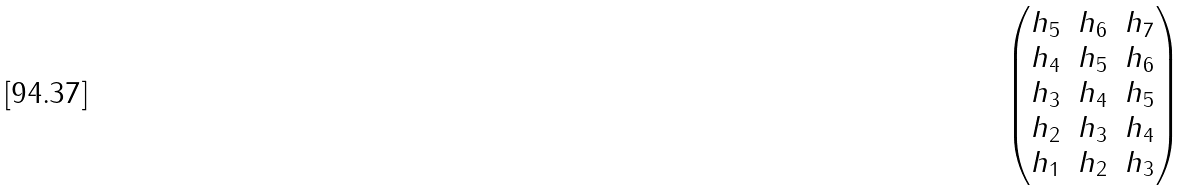Convert formula to latex. <formula><loc_0><loc_0><loc_500><loc_500>\begin{pmatrix} h _ { 5 } & h _ { 6 } & h _ { 7 } \\ h _ { 4 } & h _ { 5 } & h _ { 6 } \\ h _ { 3 } & h _ { 4 } & h _ { 5 } \\ h _ { 2 } & h _ { 3 } & h _ { 4 } \\ h _ { 1 } & h _ { 2 } & h _ { 3 } \end{pmatrix}</formula> 